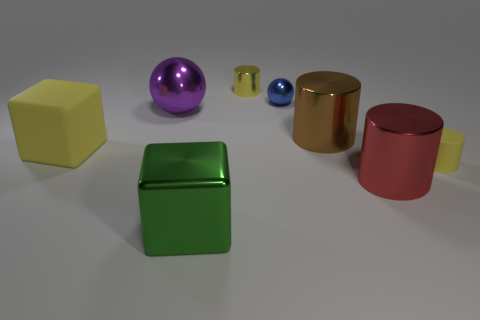How many shiny cylinders are both behind the brown thing and to the right of the brown cylinder? 0 